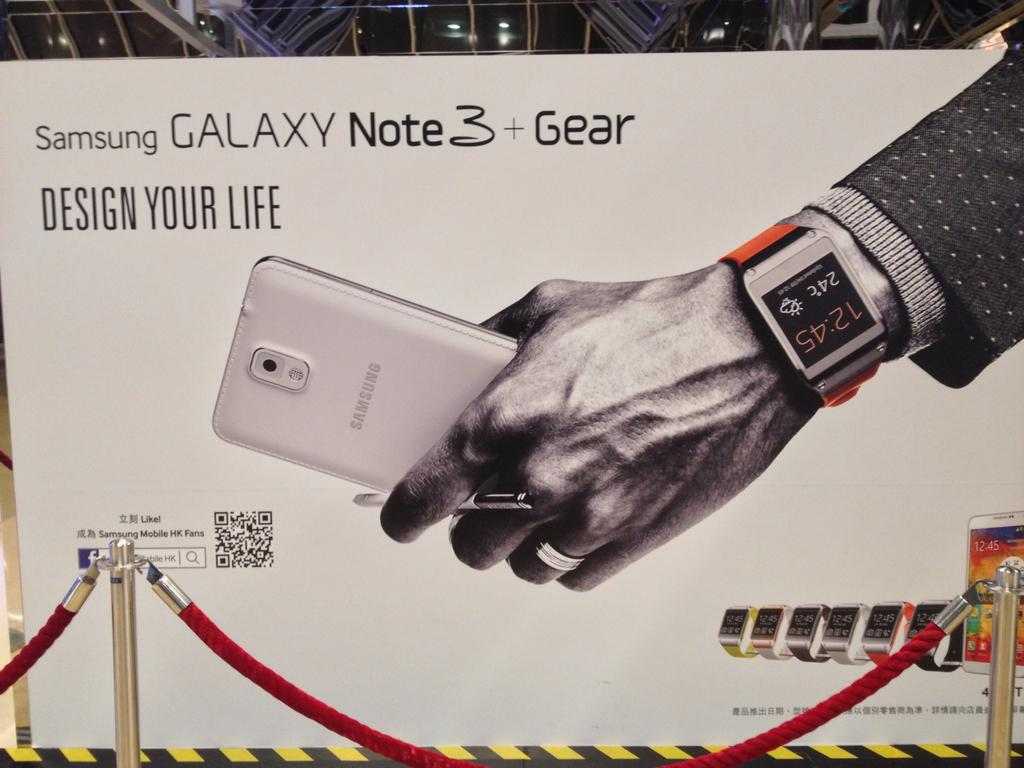Provide a one-sentence caption for the provided image. An ad for the Samsung Galaxy Note 3 shows a man's hand holding the phone. 